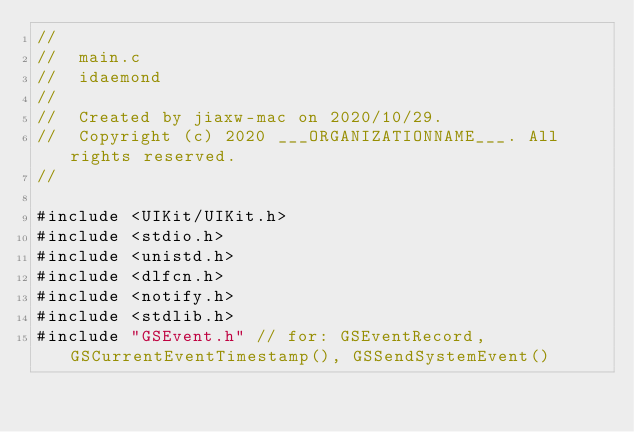Convert code to text. <code><loc_0><loc_0><loc_500><loc_500><_ObjectiveC_>//
//  main.c
//  idaemond
//
//  Created by jiaxw-mac on 2020/10/29.
//  Copyright (c) 2020 ___ORGANIZATIONNAME___. All rights reserved.
//

#include <UIKit/UIKit.h>
#include <stdio.h>
#include <unistd.h>
#include <dlfcn.h>
#include <notify.h>
#include <stdlib.h>
#include "GSEvent.h" // for: GSEventRecord, GSCurrentEventTimestamp(), GSSendSystemEvent()
</code> 